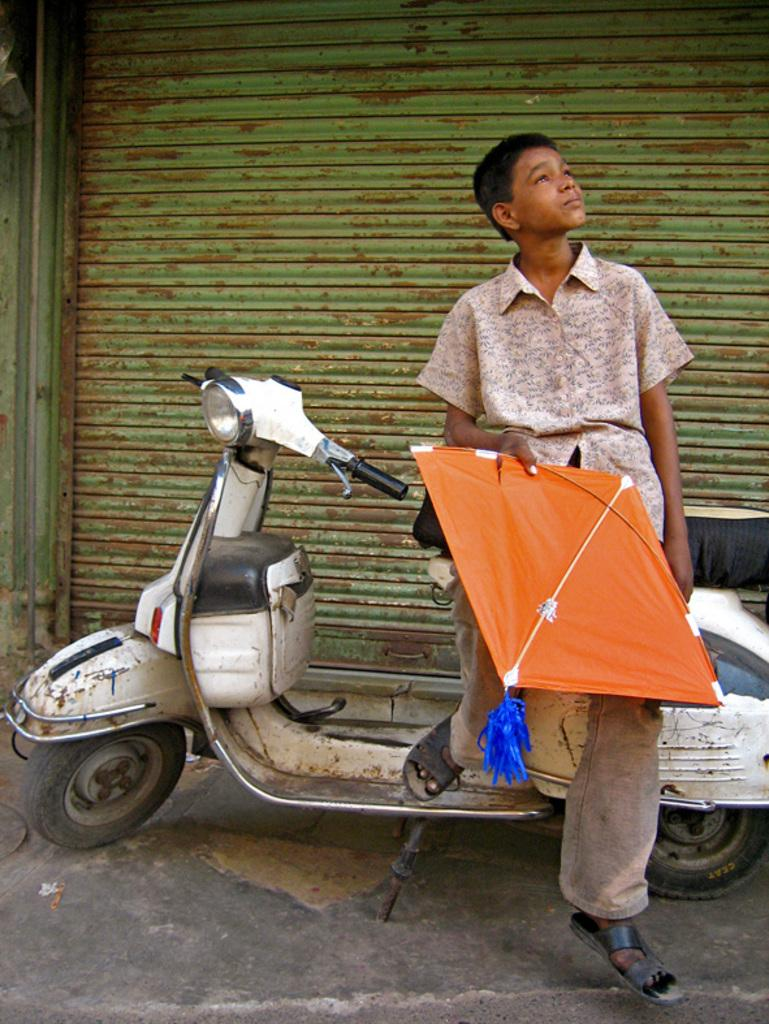Who is the main subject in the image? There is a boy in the image. What is the boy doing in the image? The boy is sitting on a scooter. What is the boy holding in his right hand? The boy is holding orange color kites in his right hand. What can be seen behind the boy? There is a shutter behind the boy. What type of trousers is the boy wearing in the image? The provided facts do not mention the type of trousers the boy is wearing. What agreement was reached between the boy and the kites in the image? There is no indication of any agreement between the boy and the kites in the image. 